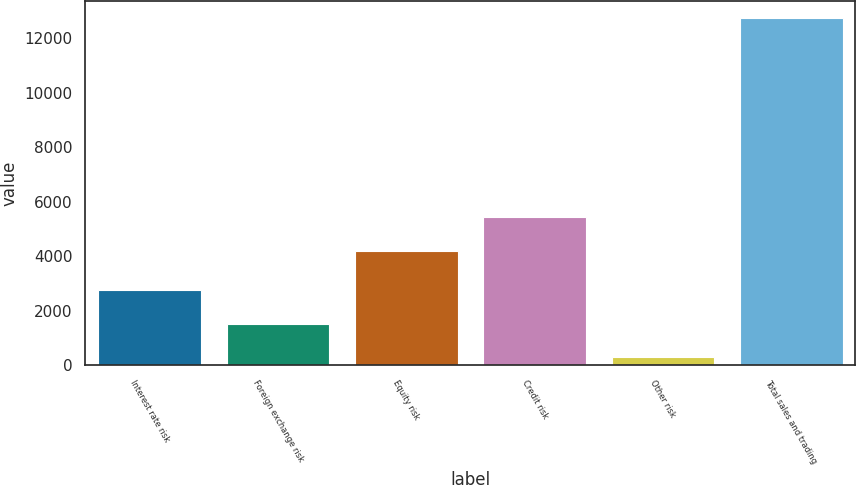<chart> <loc_0><loc_0><loc_500><loc_500><bar_chart><fcel>Interest rate risk<fcel>Foreign exchange risk<fcel>Equity risk<fcel>Credit risk<fcel>Other risk<fcel>Total sales and trading<nl><fcel>2780.8<fcel>1535.9<fcel>4202<fcel>5446.9<fcel>291<fcel>12740<nl></chart> 